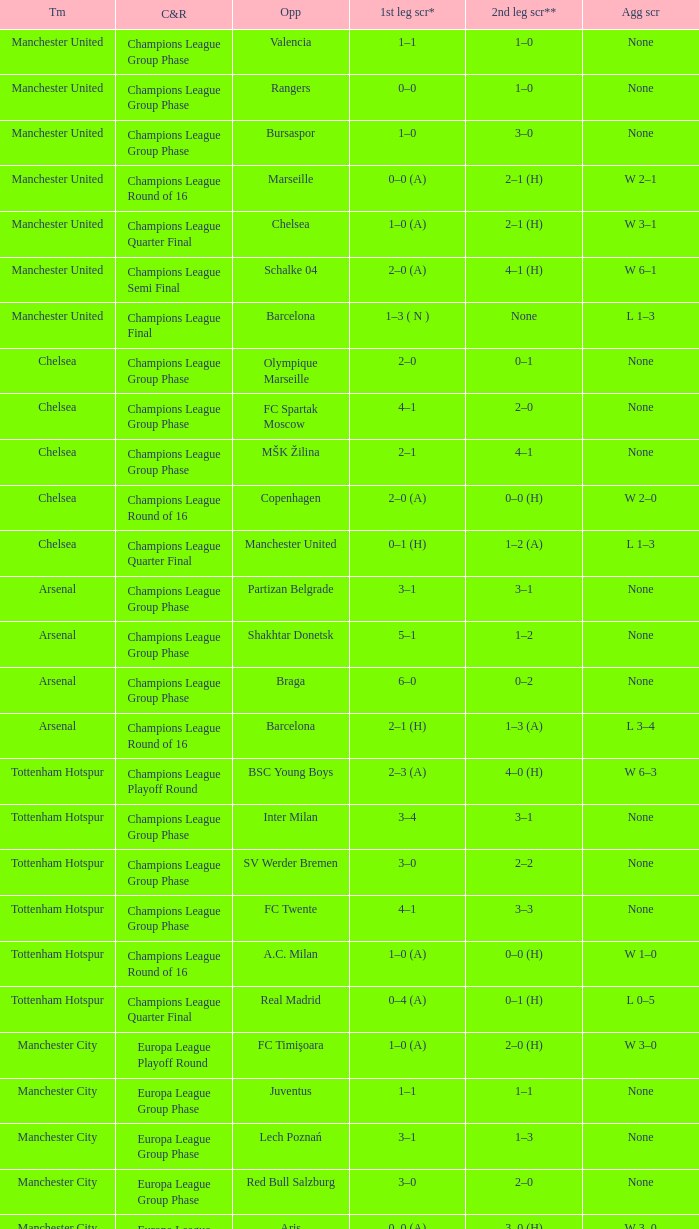What was the score between Marseille and Manchester United on the second leg of the Champions League Round of 16? 2–1 (H). 